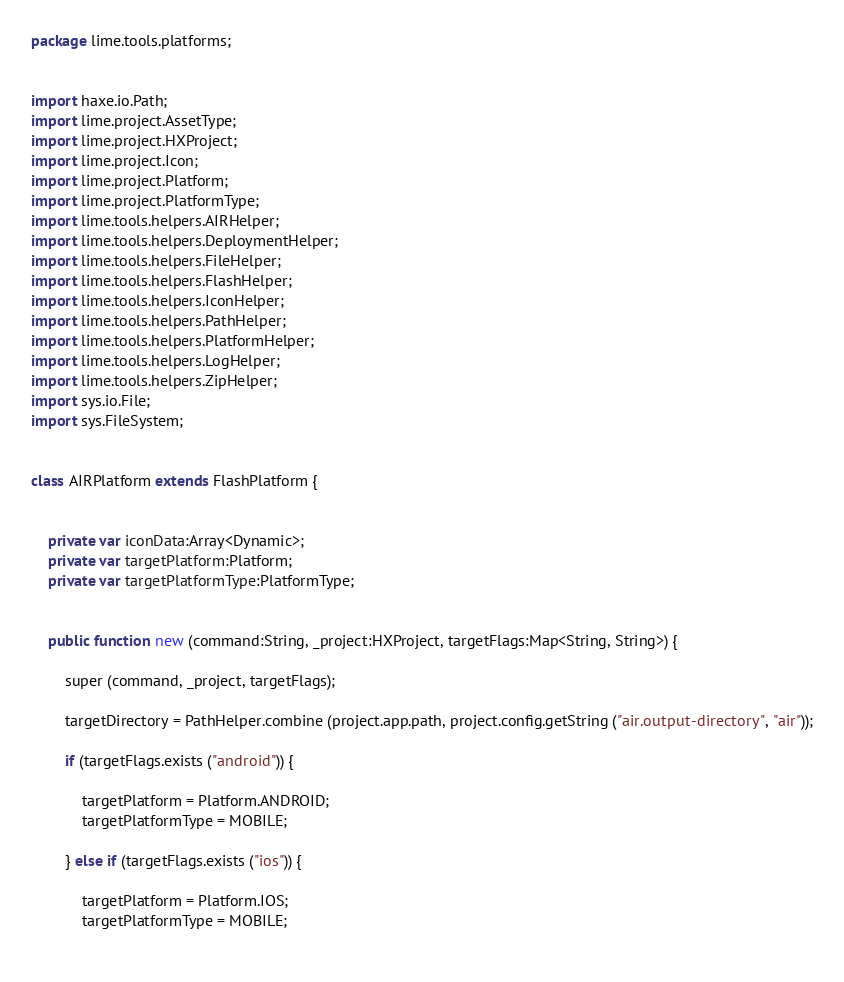Convert code to text. <code><loc_0><loc_0><loc_500><loc_500><_Haxe_>package lime.tools.platforms;


import haxe.io.Path;
import lime.project.AssetType;
import lime.project.HXProject;
import lime.project.Icon;
import lime.project.Platform;
import lime.project.PlatformType;
import lime.tools.helpers.AIRHelper;
import lime.tools.helpers.DeploymentHelper;
import lime.tools.helpers.FileHelper;
import lime.tools.helpers.FlashHelper;
import lime.tools.helpers.IconHelper;
import lime.tools.helpers.PathHelper;
import lime.tools.helpers.PlatformHelper;
import lime.tools.helpers.LogHelper;
import lime.tools.helpers.ZipHelper;
import sys.io.File;
import sys.FileSystem;


class AIRPlatform extends FlashPlatform {
	
	
	private var iconData:Array<Dynamic>;
	private var targetPlatform:Platform;
	private var targetPlatformType:PlatformType;
	
	
	public function new (command:String, _project:HXProject, targetFlags:Map<String, String>) {
		
		super (command, _project, targetFlags);
		
		targetDirectory = PathHelper.combine (project.app.path, project.config.getString ("air.output-directory", "air"));
		
		if (targetFlags.exists ("android")) {
			
			targetPlatform = Platform.ANDROID;
			targetPlatformType = MOBILE;
			
		} else if (targetFlags.exists ("ios")) {
			
			targetPlatform = Platform.IOS;
			targetPlatformType = MOBILE;
			</code> 